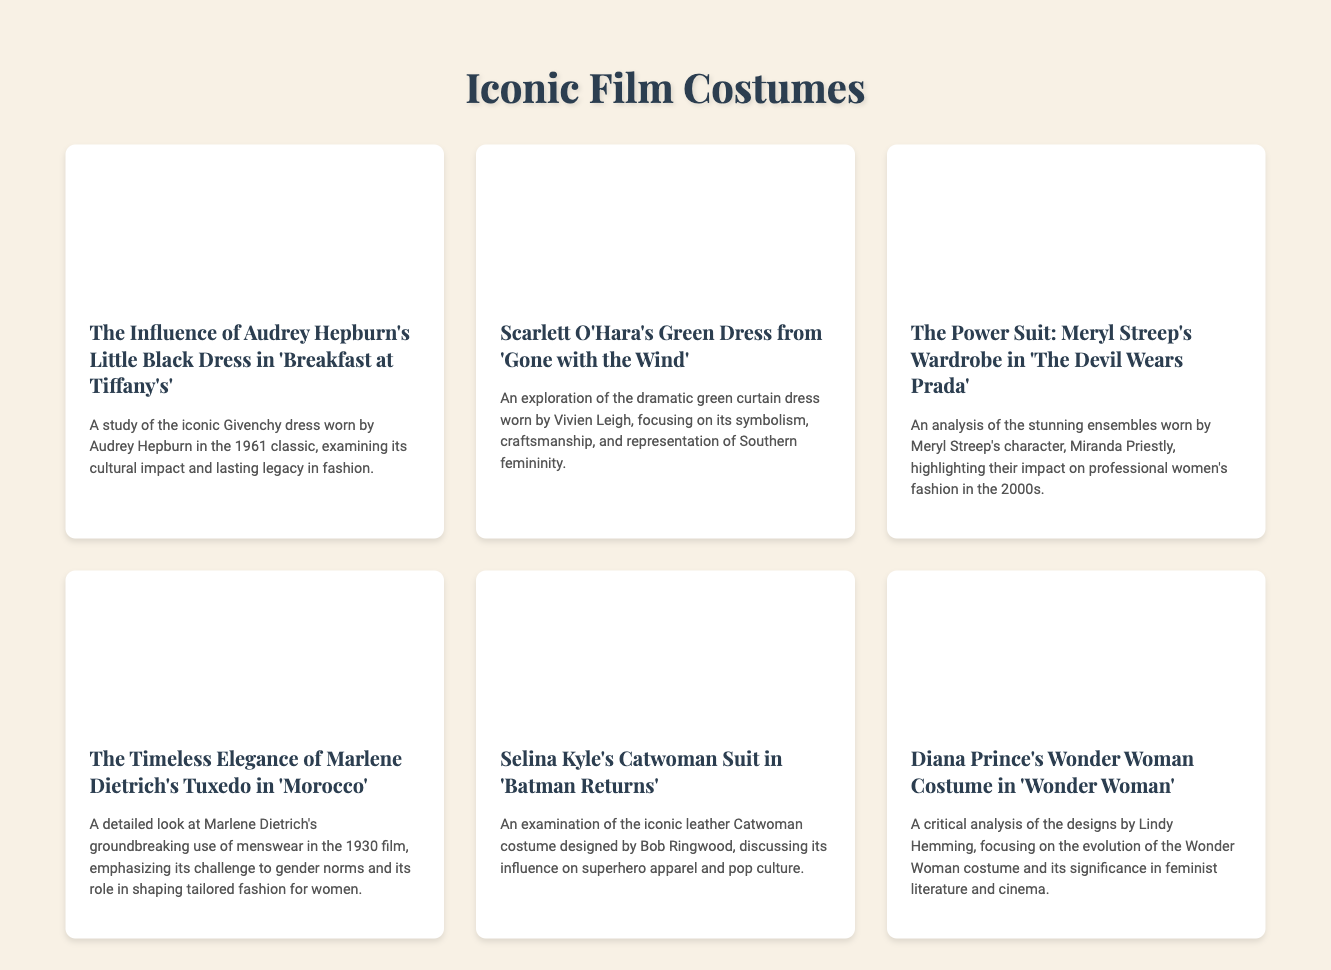What is the title of the first menu item? The title of the first menu item is the header presented in the first section of the document, "The Influence of Audrey Hepburn's Little Black Dress in 'Breakfast at Tiffany's'."
Answer: The Influence of Audrey Hepburn's Little Black Dress in 'Breakfast at Tiffany's' Who wore the green dress in 'Gone with the Wind'? The document mentions Vivien Leigh as the actress who wore the iconic green dress in the film 'Gone with the Wind'.
Answer: Vivien Leigh How many menu items are there in total? The number of menu items can be counted from the document content, which lists six specific iconic film costumes.
Answer: 6 What costume is analyzed in relation to professional women's fashion? The document states that Meryl Streep's wardrobe in 'The Devil Wears Prada' is the focus of the analysis regarding professional women's fashion.
Answer: Meryl Streep's wardrobe in 'The Devil Wears Prada' What is highlighted about Marlene Dietrich's tuxedo in 'Morocco'? The document emphasizes the groundbreaking use of menswear by Marlene Dietrich in challenging gender norms through her tuxedo in 'Morocco'.
Answer: Challenge to gender norms Which superhero outfit is discussed in the context of pop culture? The examination of Selina Kyle's Catwoman suit in 'Batman Returns' discusses its influence on superhero apparel and pop culture.
Answer: Selina Kyle's Catwoman suit in 'Batman Returns' What year was 'Breakfast at Tiffany's' released? The document refers to 'Breakfast at Tiffany's' as a classic film from 1961.
Answer: 1961 